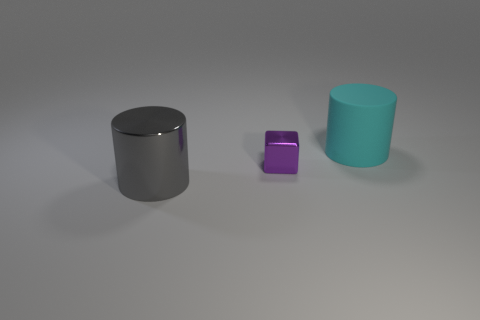Are there any other things that have the same material as the cyan cylinder?
Provide a succinct answer. No. There is a cylinder that is made of the same material as the purple thing; what size is it?
Offer a terse response. Large. What number of tiny shiny things have the same color as the large metal thing?
Give a very brief answer. 0. Is there a red metal cylinder?
Your answer should be compact. No. Is the shape of the rubber thing the same as the tiny thing left of the cyan matte cylinder?
Your answer should be compact. No. There is a cylinder that is in front of the cylinder that is behind the gray cylinder in front of the small purple cube; what is its color?
Provide a succinct answer. Gray. Are there any matte objects in front of the big cyan cylinder?
Keep it short and to the point. No. Are there any gray cylinders that have the same material as the purple object?
Make the answer very short. Yes. What is the color of the cube?
Your answer should be very brief. Purple. Is the shape of the big object to the left of the cyan rubber cylinder the same as  the small object?
Your answer should be compact. No. 